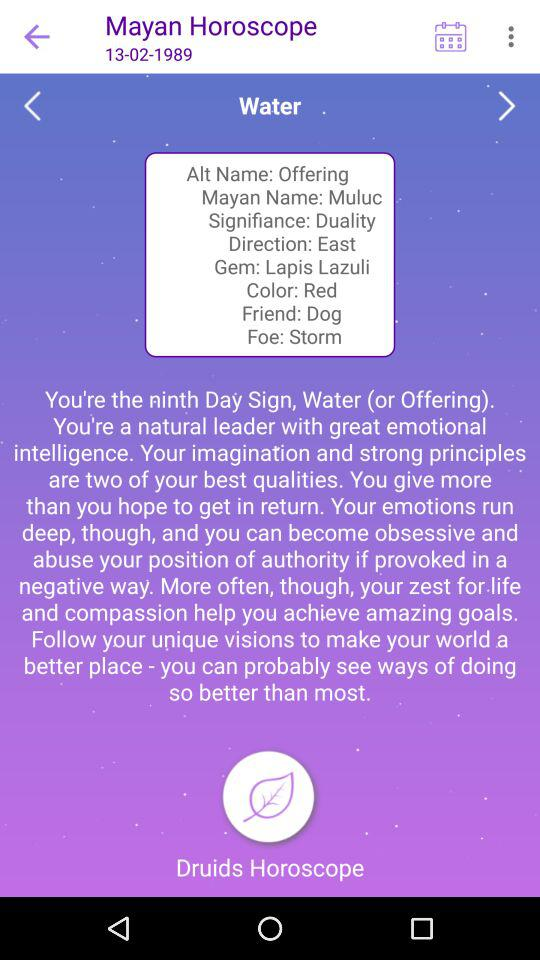What is the Gem? The Gem is "Lapis Lazuli". 